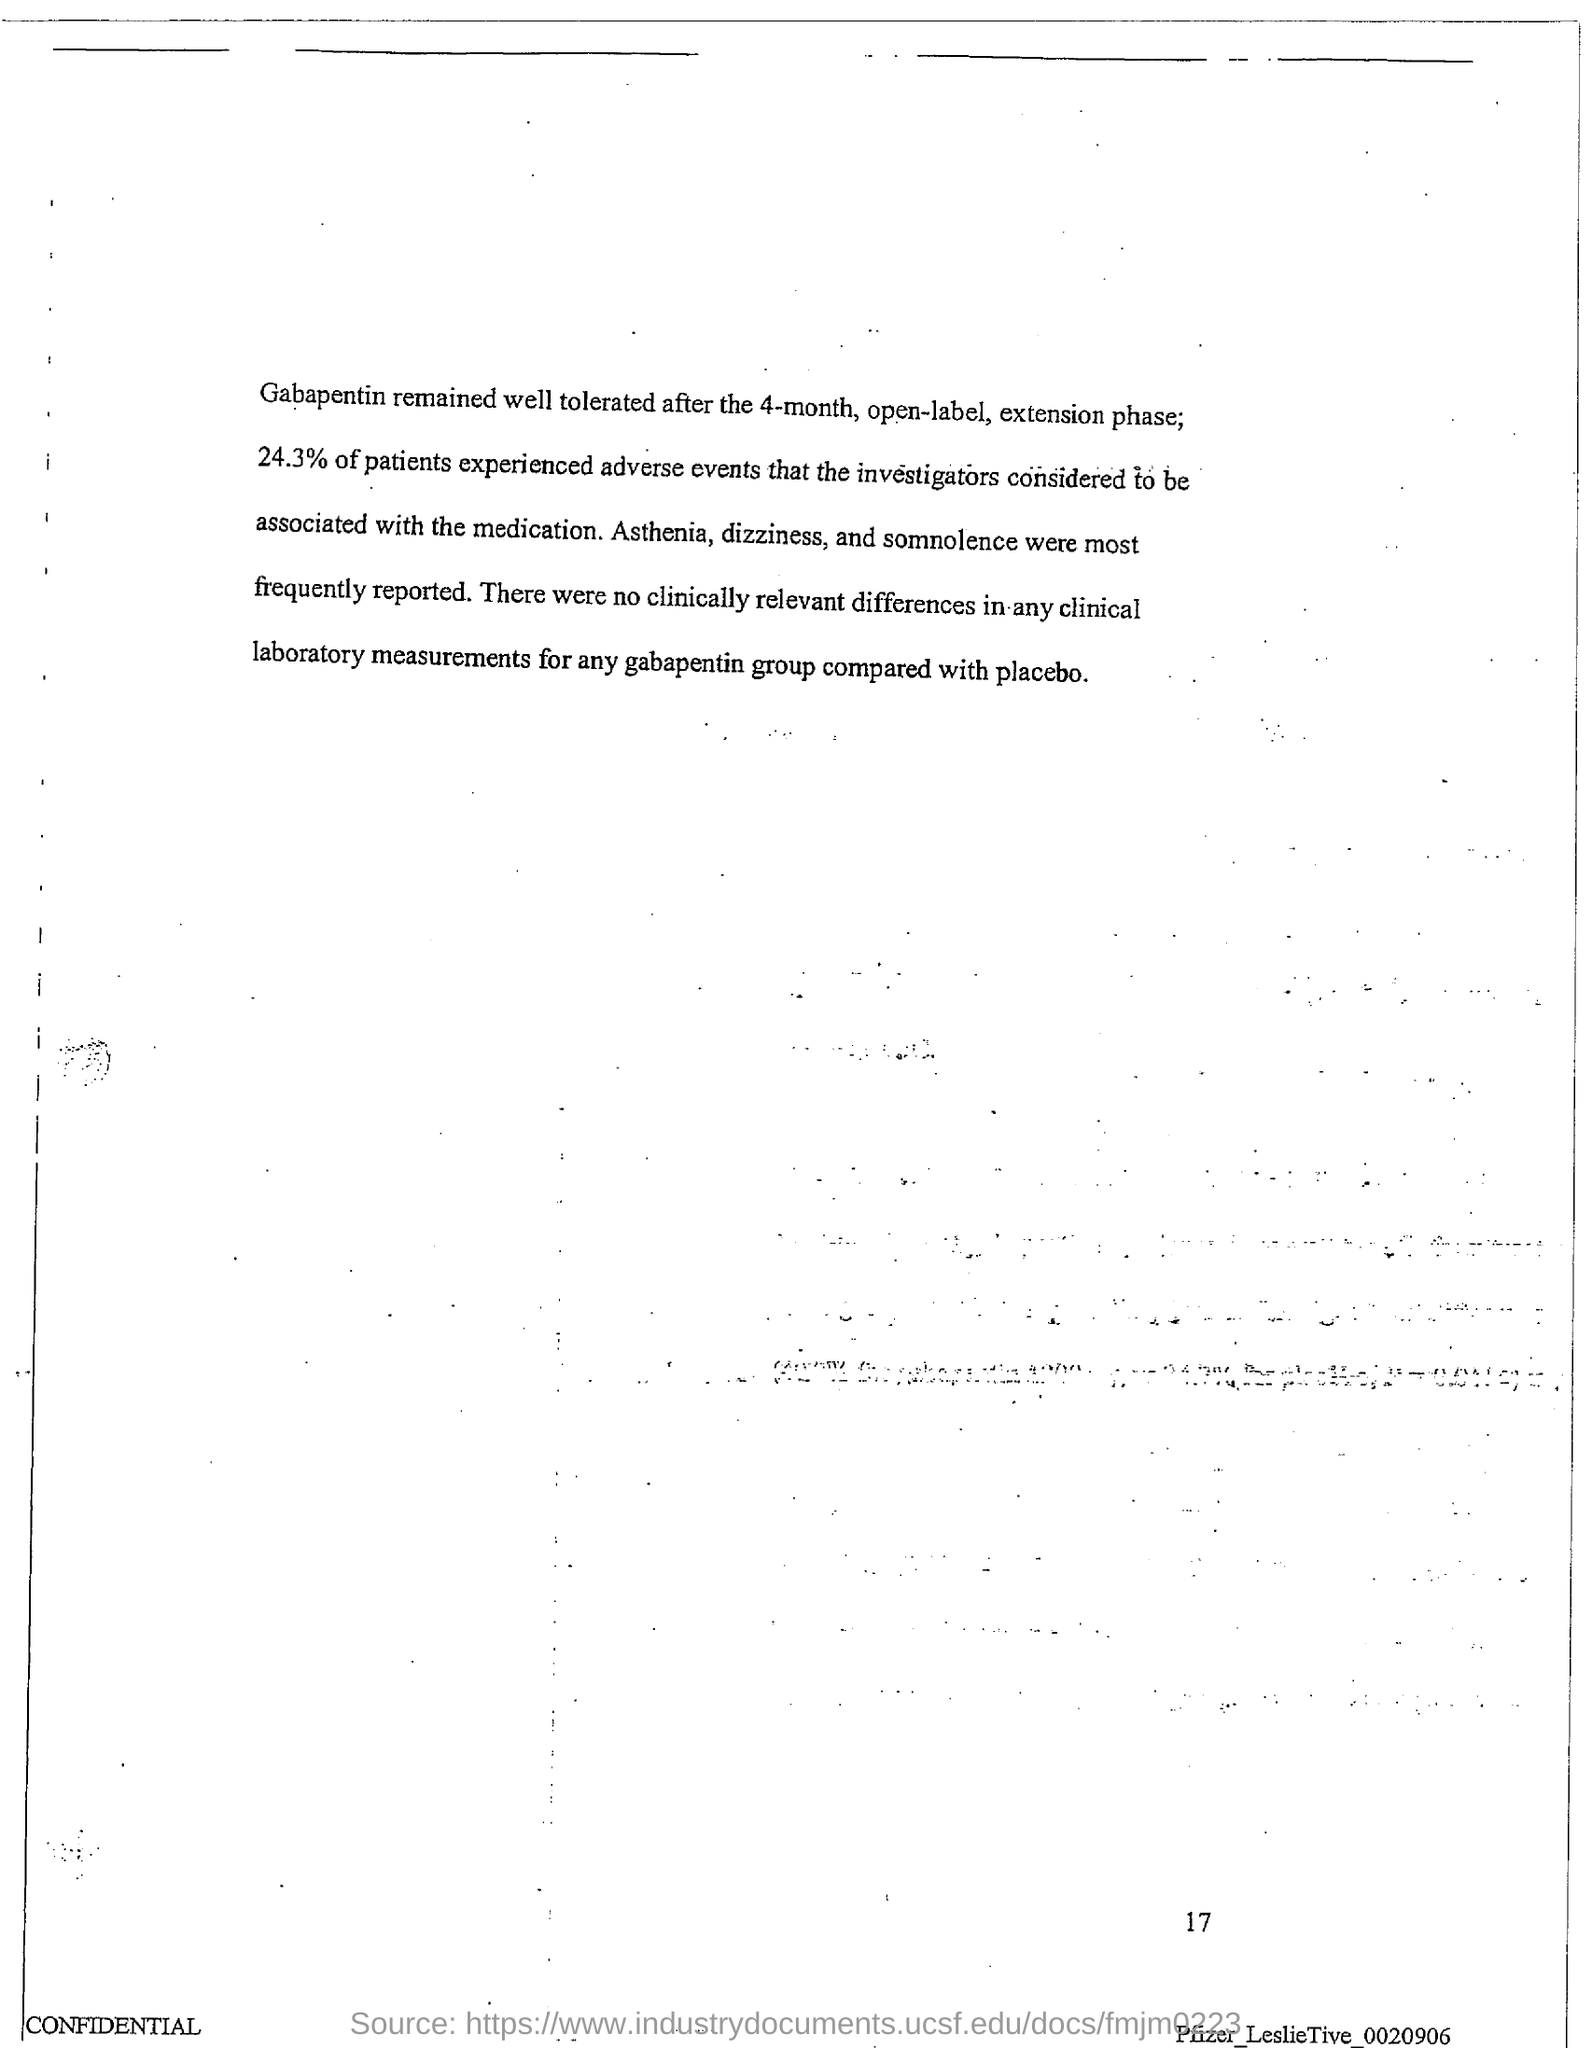Mention a couple of crucial points in this snapshot. Approximately 24.3% of patients experienced adverse events. 